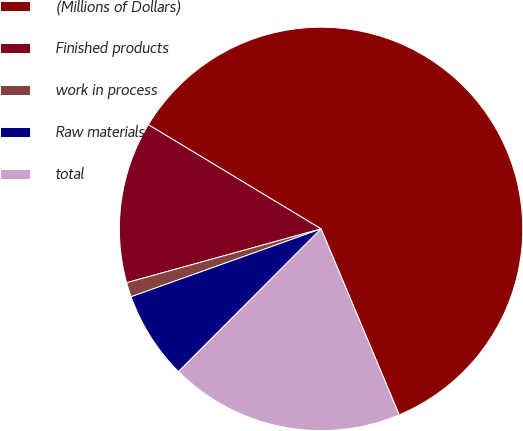Convert chart to OTSL. <chart><loc_0><loc_0><loc_500><loc_500><pie_chart><fcel>(Millions of Dollars)<fcel>Finished products<fcel>work in process<fcel>Raw materials<fcel>total<nl><fcel>60.03%<fcel>12.94%<fcel>1.16%<fcel>7.05%<fcel>18.82%<nl></chart> 